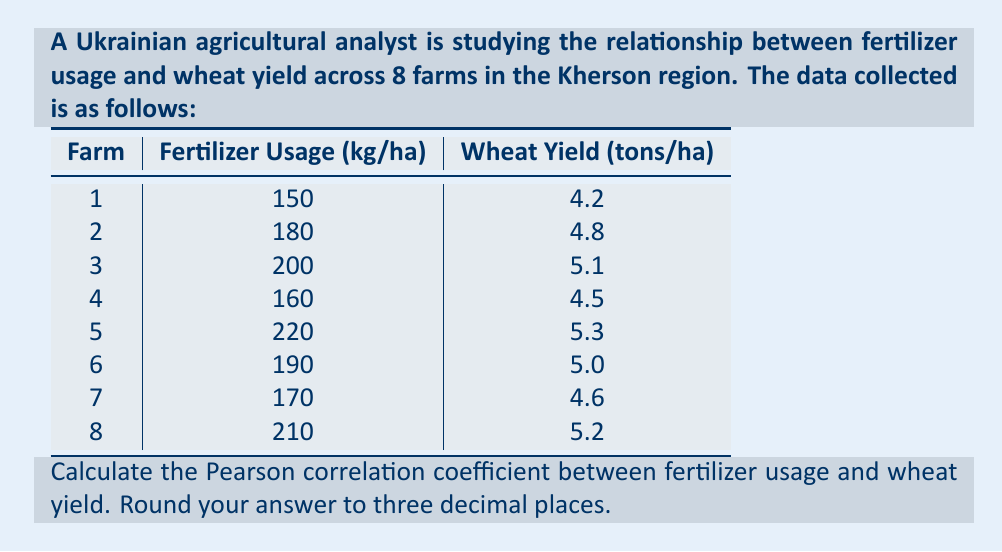Teach me how to tackle this problem. To calculate the Pearson correlation coefficient, we'll use the formula:

$$ r = \frac{\sum_{i=1}^{n} (x_i - \bar{x})(y_i - \bar{y})}{\sqrt{\sum_{i=1}^{n} (x_i - \bar{x})^2 \sum_{i=1}^{n} (y_i - \bar{y})^2}} $$

Where:
$x_i$ = fertilizer usage values
$y_i$ = wheat yield values
$\bar{x}$ = mean of fertilizer usage
$\bar{y}$ = mean of wheat yield
$n$ = number of data points (8 in this case)

Step 1: Calculate the means
$\bar{x} = \frac{150 + 180 + 200 + 160 + 220 + 190 + 170 + 210}{8} = 185$ kg/ha
$\bar{y} = \frac{4.2 + 4.8 + 5.1 + 4.5 + 5.3 + 5.0 + 4.6 + 5.2}{8} = 4.8375$ tons/ha

Step 2: Calculate $(x_i - \bar{x})$, $(y_i - \bar{y})$, $(x_i - \bar{x})^2$, $(y_i - \bar{y})^2$, and $(x_i - \bar{x})(y_i - \bar{y})$ for each data point.

Step 3: Sum up the calculated values:
$\sum (x_i - \bar{x})(y_i - \bar{y}) = 1023.75$
$\sum (x_i - \bar{x})^2 = 4550$
$\sum (y_i - \bar{y})^2 = 1.034375$

Step 4: Apply the formula:

$$ r = \frac{1023.75}{\sqrt{4550 \times 1.034375}} = \frac{1023.75}{68.5191} = 0.9945 $$

Rounding to three decimal places, we get 0.995.
Answer: 0.995 